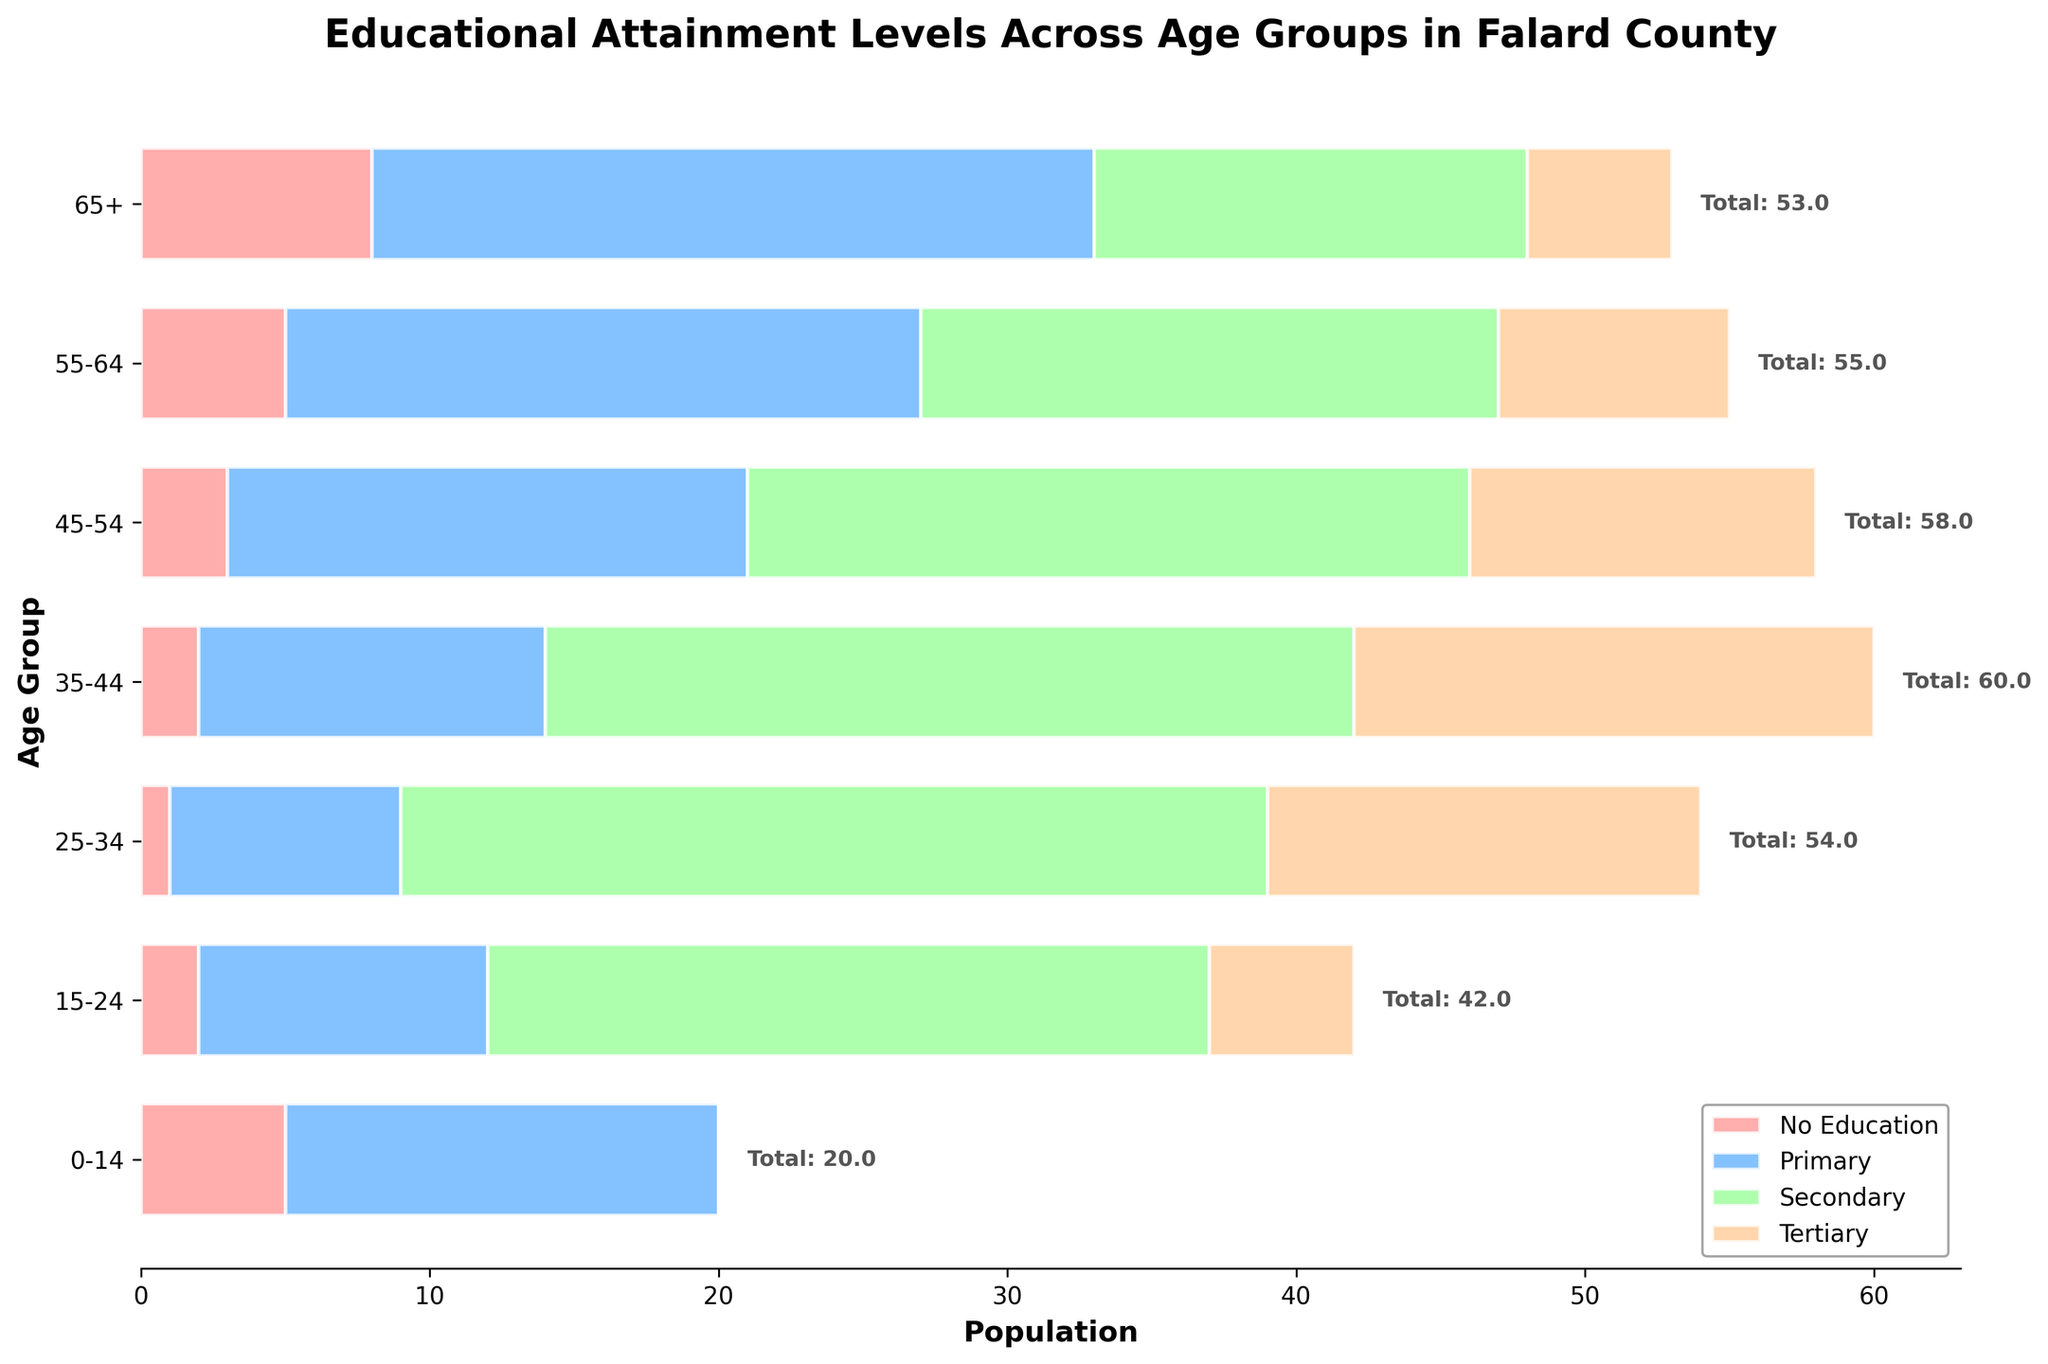What is the title of the figure? The title of the figure is displayed at the top and reads: "Educational Attainment Levels Across Age Groups in Falard County"
Answer: Educational Attainment Levels Across Age Groups in Falard County What age group has the highest population with no education? By looking at the bars labeled 'No Education' (usually the first bar on the left of each age group), the group with the longest bar is '65+'
Answer: 65+ How many people in the 25-34 age group have attained tertiary education? In the age group '25-34', the portion of the bar corresponding to 'Tertiary' education level is shown in the respective color. Based on the chart, this is represented by a value of 15
Answer: 15 Which age group has the highest total educational attainment across all levels? To find the age group with the highest total attainment, we sum the education levels for each group and compare. The 45-54 group sums up to 58, which is the highest
Answer: 45-54 What is the total number of people in the '35-44' age group? Summing up the values for the '35-44' age group across all education levels: 2 (No Education) + 12 (Primary) + 28 (Secondary) + 18 (Tertiary) = 60
Answer: 60 Which group has more people with secondary education, '55-64' or '65+'? Comparing the bars: '55-64' has 20 people with secondary education, while '65+' has 15
Answer: 55-64 Is there any age group where more people have tertiary education compared to secondary education? In the '35-44' age group, there are 18 people with tertiary education and 28 with secondary, so no age group has more tertiary than secondary education
Answer: No Which educational category has the least variance across age groups? We look at the consistency of the bar lengths for each educational category across the various age groups. 'No Education' tends to have the least variance as its values are closer across groups
Answer: No Education How many people have primary education in the 0-14 and 15-24 age groups combined? Adding the Primary education values for the two groups: 15 (0-14) + 10 (15-24) = 25
Answer: 25 Do older age groups generally have higher numbers of primary education attainment compared to younger age groups? By observing the length of the 'Primary' education bars from each older age segment (55-64 and 65+) compared to younger ones (0-14 and 15-24): older age groups tend to have higher primary education numbers
Answer: Yes 